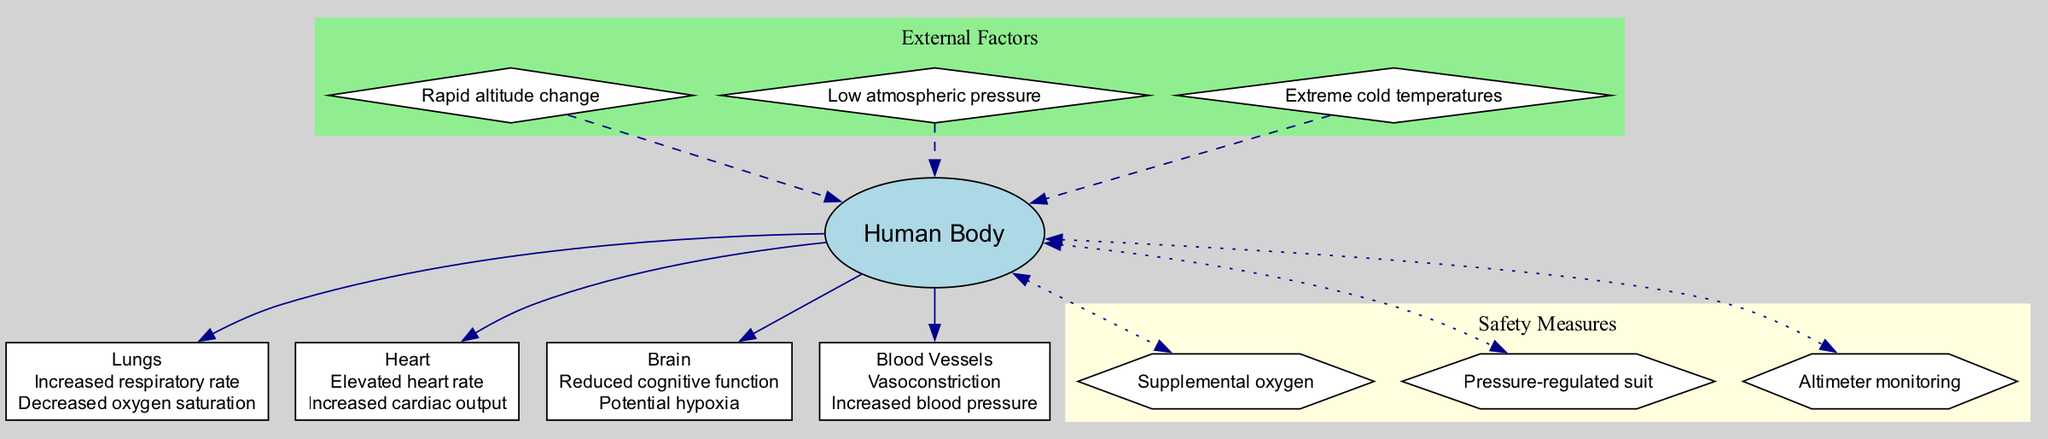What are the effects on the lungs during high-altitude jumps? The diagram shows that the lungs experience an increased respiratory rate and decreased oxygen saturation during high-altitude jumps. These effects are indicated in the node labeled "Lungs."
Answer: Increased respiratory rate, Decreased oxygen saturation How many external factors are listed in the diagram? The diagram presents three external factors affecting physiological responses during high-altitude jumps. They are labeled as diamonds under the "External Factors" subgraph.
Answer: 3 What is the effect on the heart during high-altitude jumps? According to the diagram, the heart experiences an elevated heart rate and increased cardiac output during high-altitude jumps. This is noted in the "Heart" node.
Answer: Elevated heart rate, Increased cardiac output What is indicated as a safety measure in the diagram? The diagram lists three safety measures to avoid adverse physiological effects during high-altitude jumps. They are presented as hexagons labeled under "Safety Measures."
Answer: Supplemental oxygen, Pressure-regulated suit, Altimeter monitoring What happens to blood pressure during high-altitude jumps? The diagram indicates that blood pressure increases during high-altitude jumps, as shown in the "Blood Vessels" node. This is due to vasoconstriction, which raises blood pressure.
Answer: Increased blood pressure Explain the relationship between reduced cognitive function and brain effects at high altitude. The effect of reduced cognitive function is displayed in the "Brain" node, which emphasizes that during high-altitude jumps, individuals may experience hypoxia, leading to a decline in cognitive capabilities. This correlation underscores how oxygen levels influence cognitive performance.
Answer: Reduced cognitive function How are external factors represented in the diagram? The external factors are depicted as diamonds grouped in a subgraph labeled "External Factors." They are represented with dashed edges pointing towards the main body, illustrating their external influence on the physiological responses.
Answer: Diamonds with dashed edges What physiological effect is related to vasoconstriction? The diagram connects vasoconstriction to increased blood pressure under the "Blood Vessels" node, indicating that vasoconstriction is a key physiological response during high-altitude conditions.
Answer: Increased blood pressure 